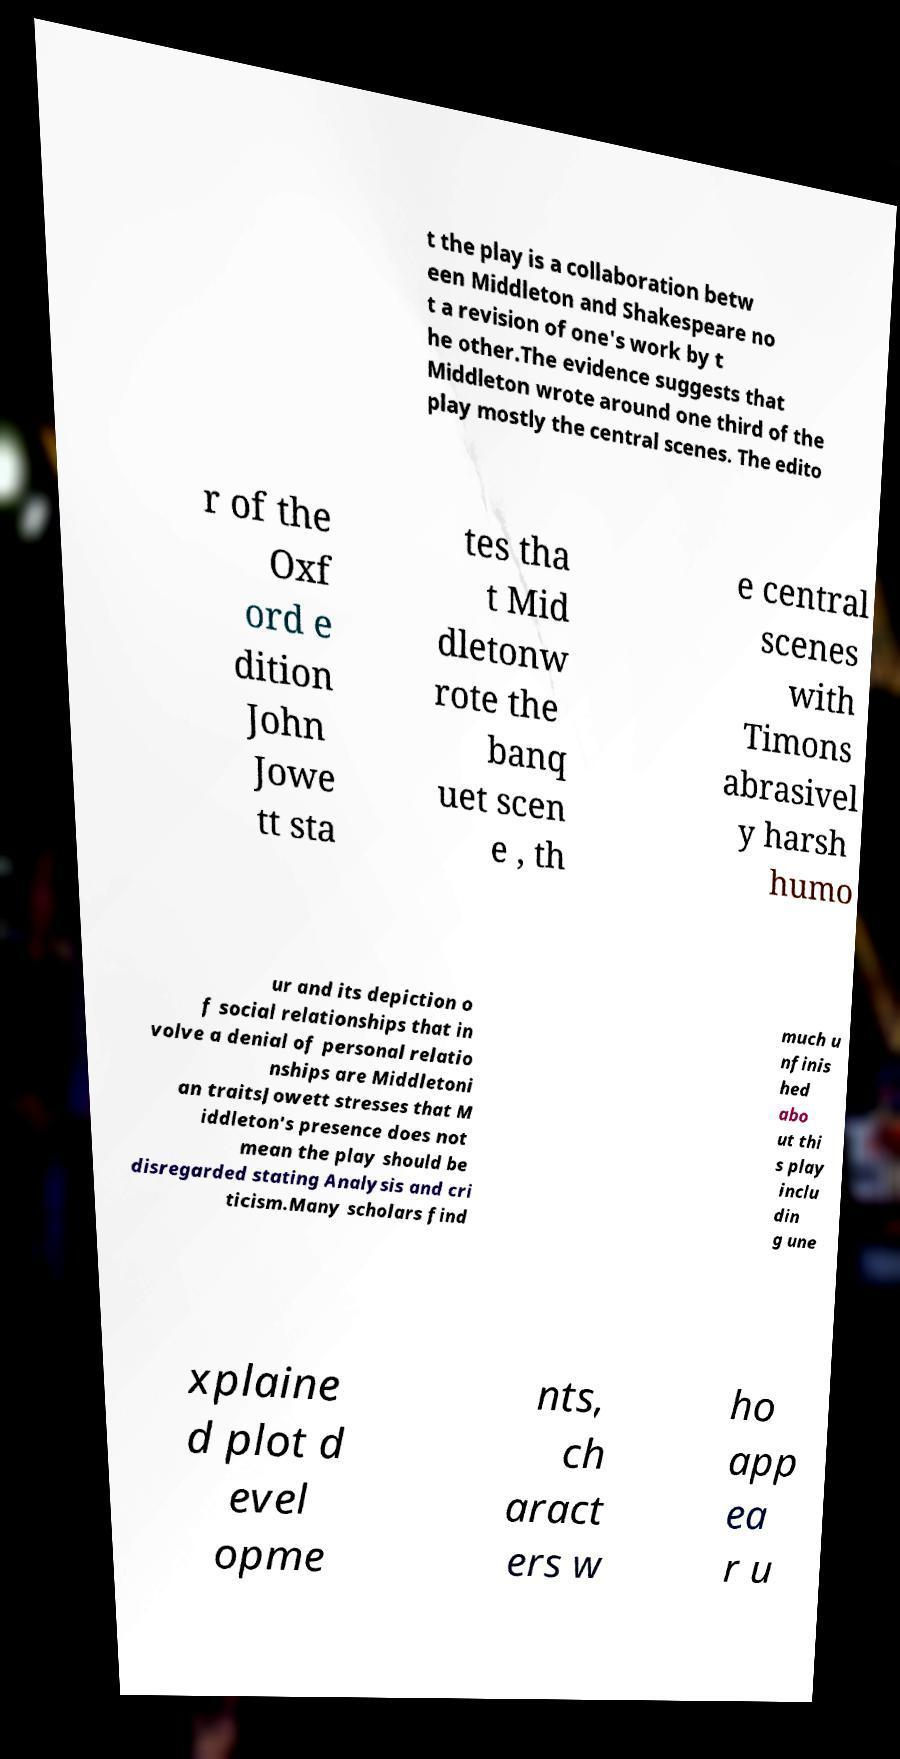I need the written content from this picture converted into text. Can you do that? t the play is a collaboration betw een Middleton and Shakespeare no t a revision of one's work by t he other.The evidence suggests that Middleton wrote around one third of the play mostly the central scenes. The edito r of the Oxf ord e dition John Jowe tt sta tes tha t Mid dletonw rote the banq uet scen e , th e central scenes with Timons abrasivel y harsh humo ur and its depiction o f social relationships that in volve a denial of personal relatio nships are Middletoni an traitsJowett stresses that M iddleton's presence does not mean the play should be disregarded stating Analysis and cri ticism.Many scholars find much u nfinis hed abo ut thi s play inclu din g une xplaine d plot d evel opme nts, ch aract ers w ho app ea r u 